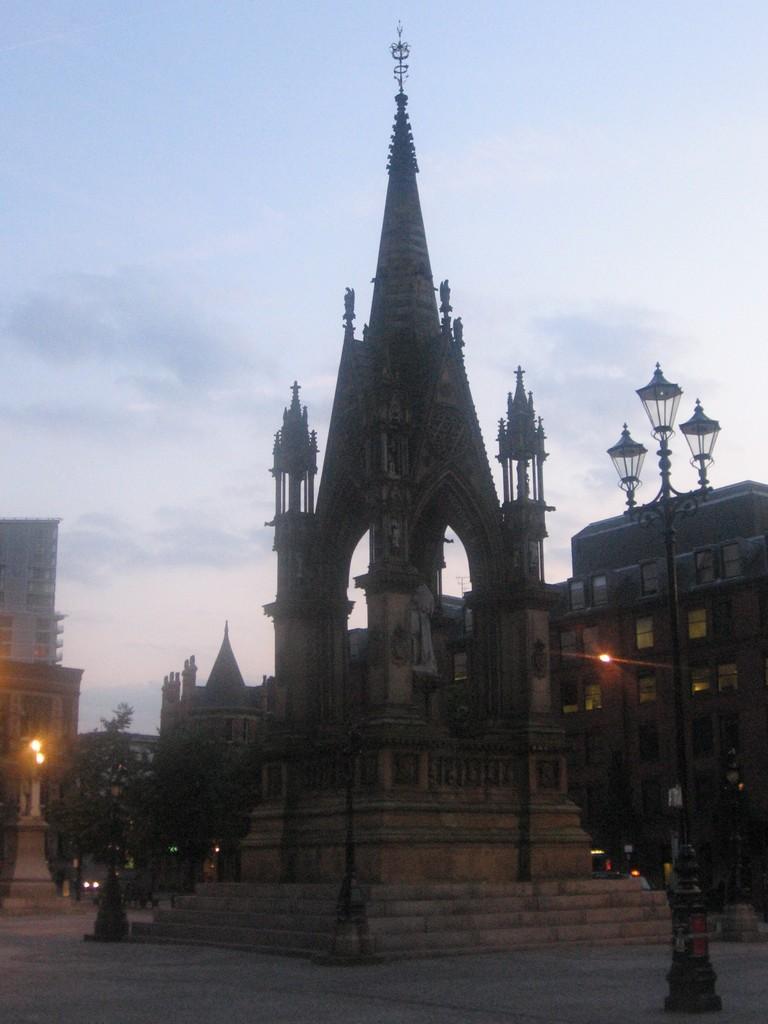Please provide a concise description of this image. In this image I can see a building, a street light pole, a tree and few lights. In the background I can see few trees, few buildings, few vehicles on the road and the sky. 